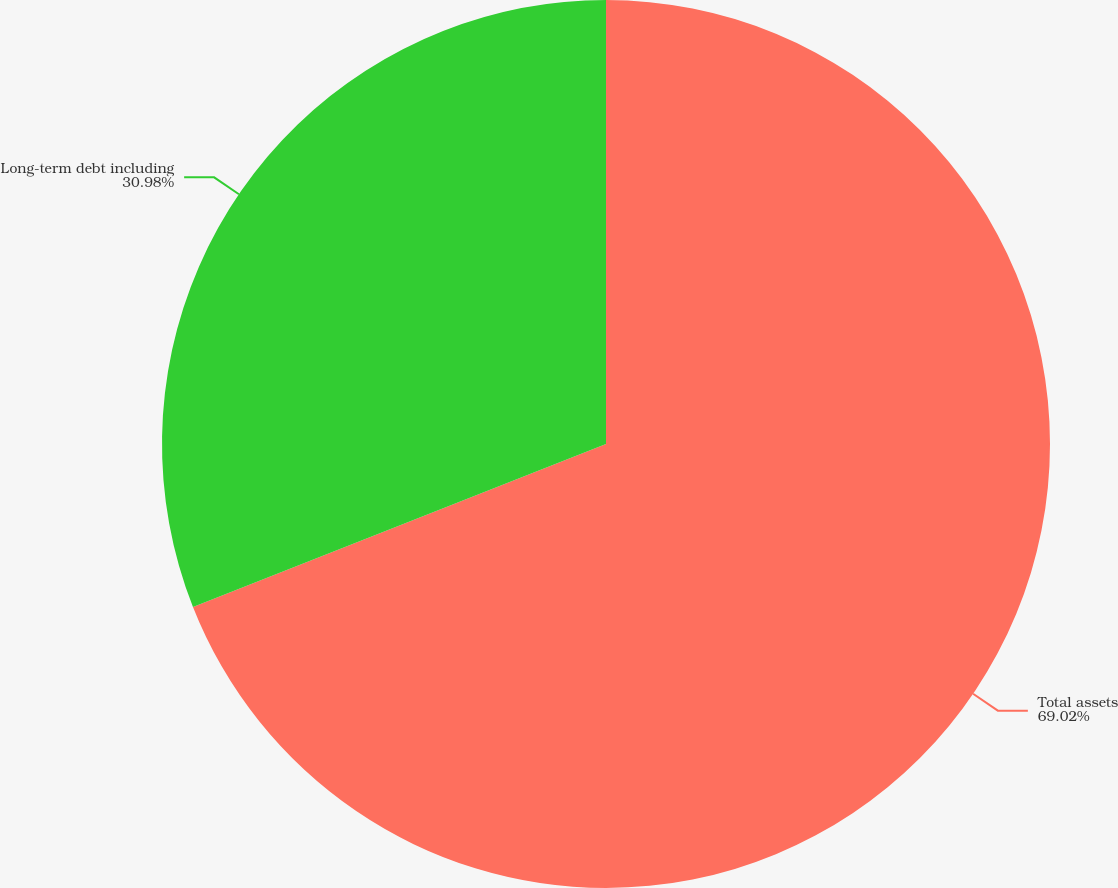<chart> <loc_0><loc_0><loc_500><loc_500><pie_chart><fcel>Total assets<fcel>Long-term debt including<nl><fcel>69.02%<fcel>30.98%<nl></chart> 